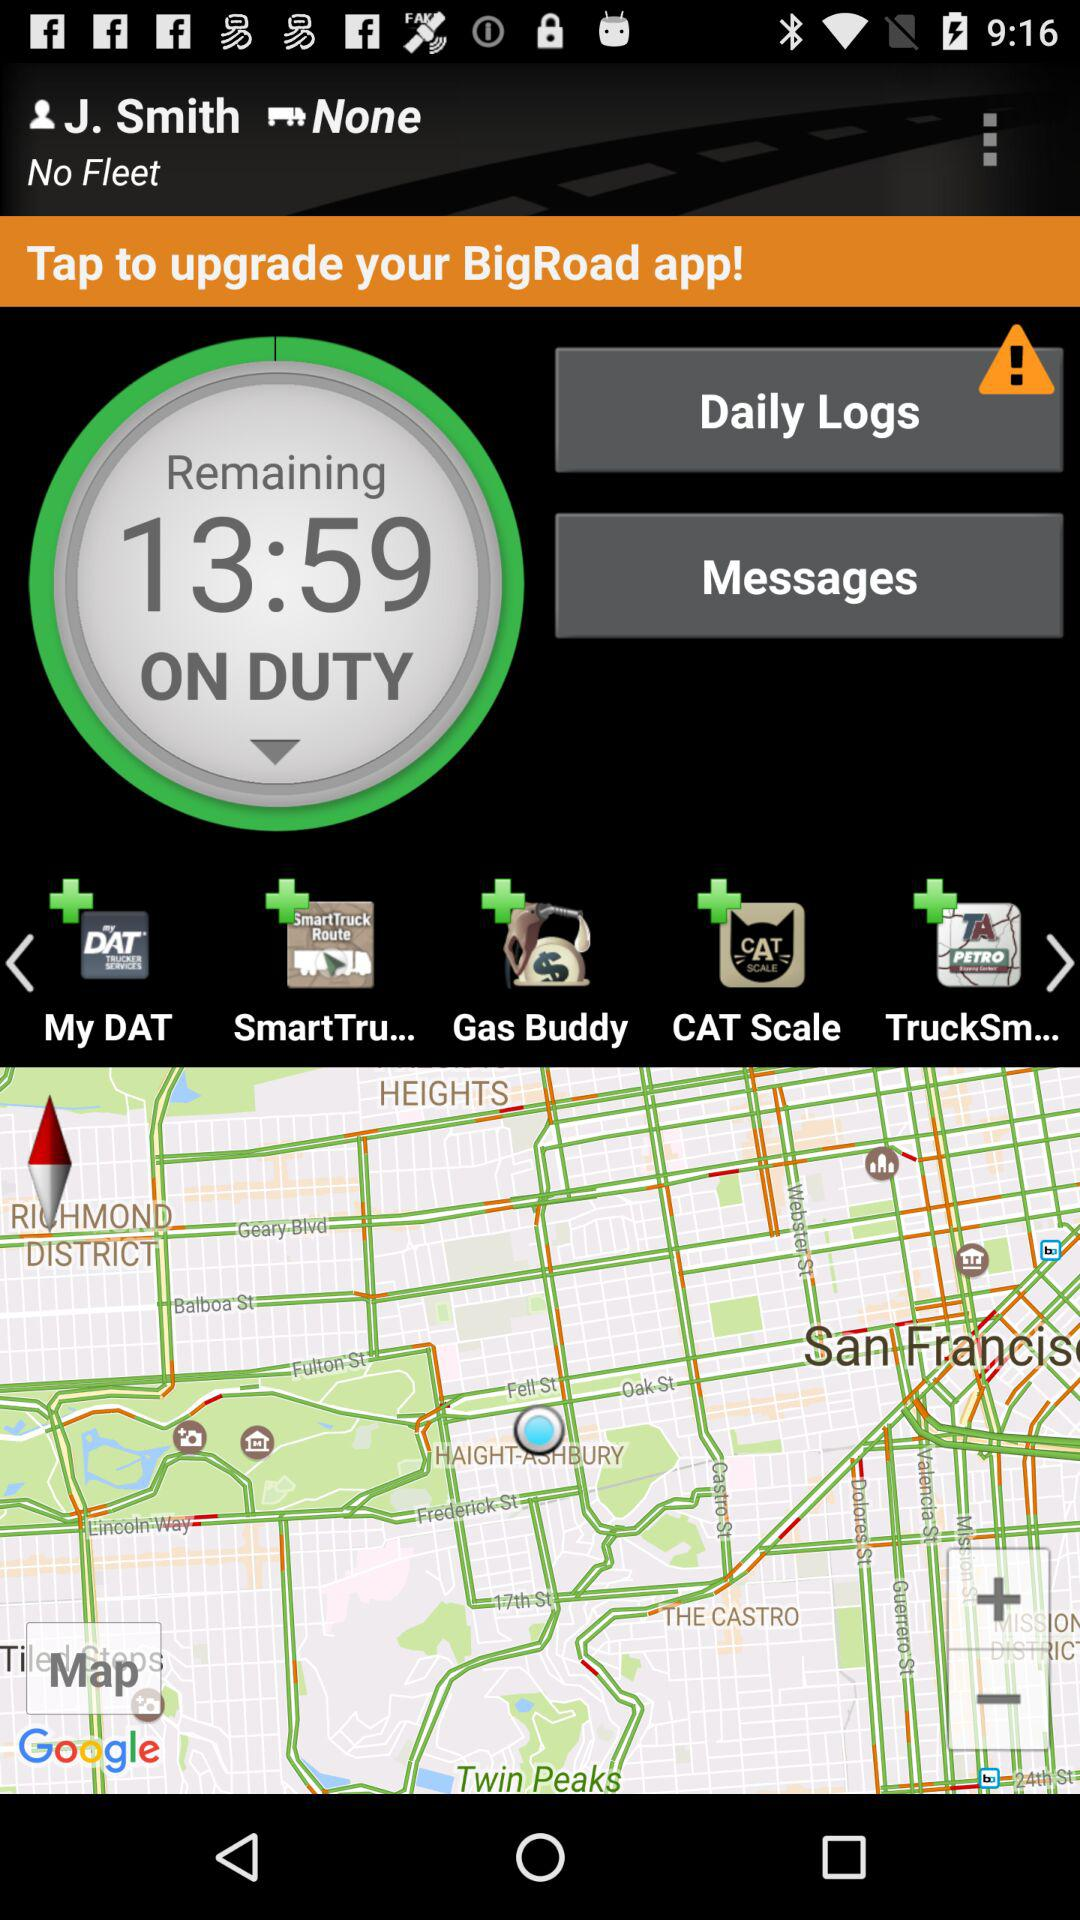How much time is remaining on duty? The time remaining on duty is 13 minutes 59 seconds. 